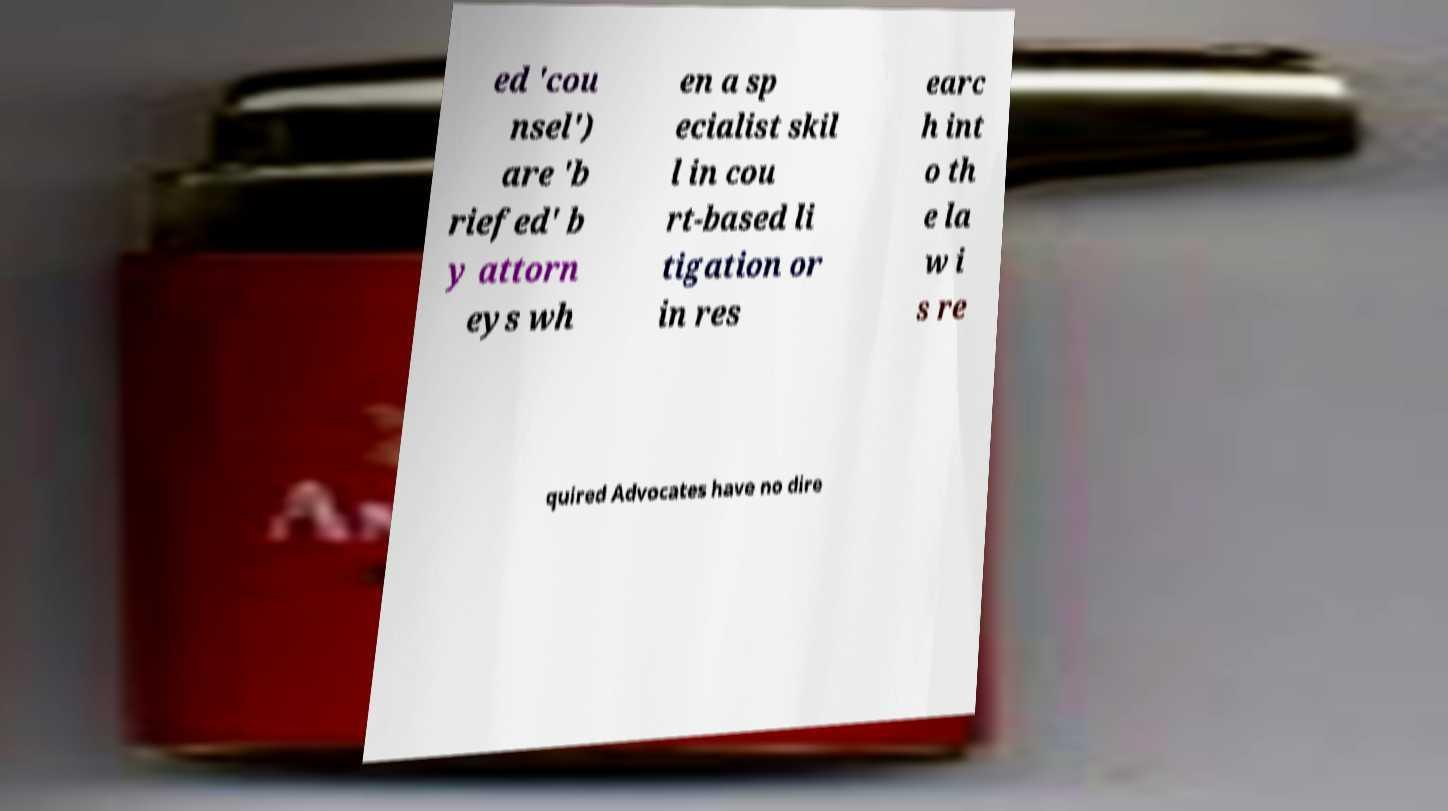What messages or text are displayed in this image? I need them in a readable, typed format. ed 'cou nsel') are 'b riefed' b y attorn eys wh en a sp ecialist skil l in cou rt-based li tigation or in res earc h int o th e la w i s re quired Advocates have no dire 